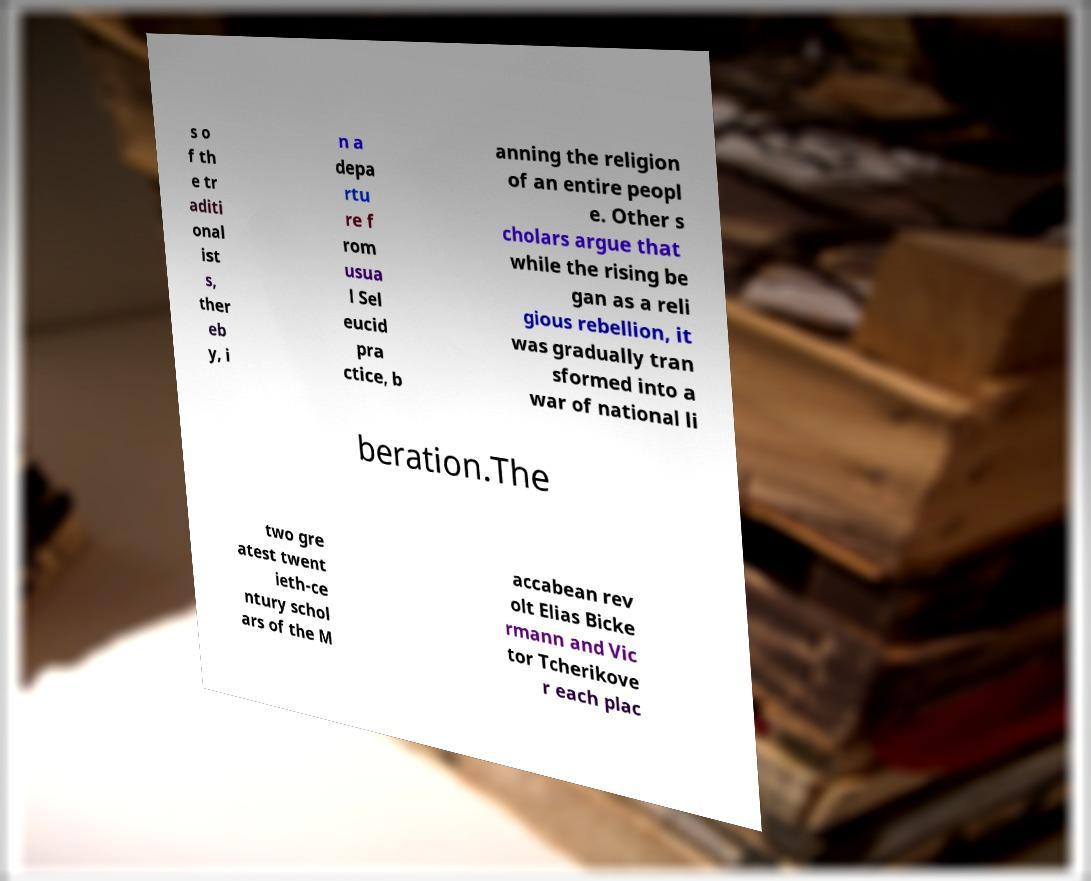Can you read and provide the text displayed in the image?This photo seems to have some interesting text. Can you extract and type it out for me? s o f th e tr aditi onal ist s, ther eb y, i n a depa rtu re f rom usua l Sel eucid pra ctice, b anning the religion of an entire peopl e. Other s cholars argue that while the rising be gan as a reli gious rebellion, it was gradually tran sformed into a war of national li beration.The two gre atest twent ieth-ce ntury schol ars of the M accabean rev olt Elias Bicke rmann and Vic tor Tcherikove r each plac 